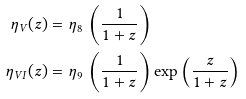Convert formula to latex. <formula><loc_0><loc_0><loc_500><loc_500>\eta _ { V } ( z ) & = \eta _ { 8 } \, \left ( \frac { 1 } { 1 + z } \right ) \\ { \eta _ { V I } } ( z ) & = \eta _ { 9 } \, \left ( \frac { 1 } { 1 + z } \right ) \exp \left ( \frac { z } { 1 + z } \right )</formula> 